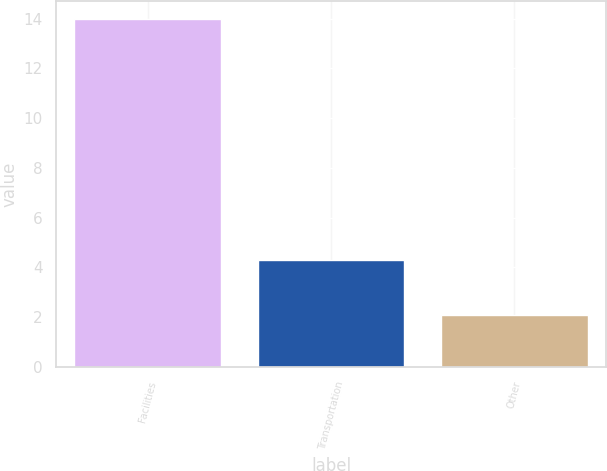<chart> <loc_0><loc_0><loc_500><loc_500><bar_chart><fcel>Facilities<fcel>Transportation<fcel>Other<nl><fcel>14<fcel>4.3<fcel>2.1<nl></chart> 